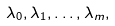<formula> <loc_0><loc_0><loc_500><loc_500>\lambda _ { 0 } , \lambda _ { 1 } , \dots , \lambda _ { m } ,</formula> 